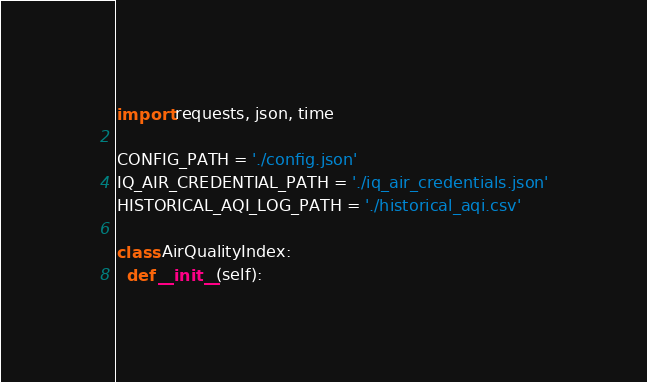<code> <loc_0><loc_0><loc_500><loc_500><_Python_>import requests, json, time

CONFIG_PATH = './config.json'
IQ_AIR_CREDENTIAL_PATH = './iq_air_credentials.json'
HISTORICAL_AQI_LOG_PATH = './historical_aqi.csv'

class AirQualityIndex:
  def __init__(self):</code> 